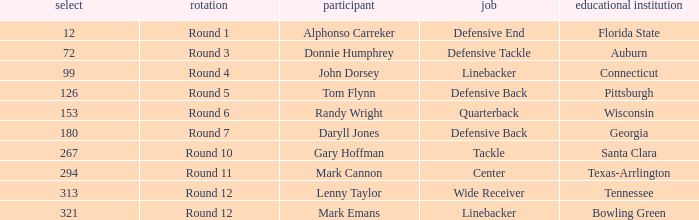What is Mark Cannon's College? Texas-Arrlington. 